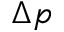<formula> <loc_0><loc_0><loc_500><loc_500>\Delta p</formula> 